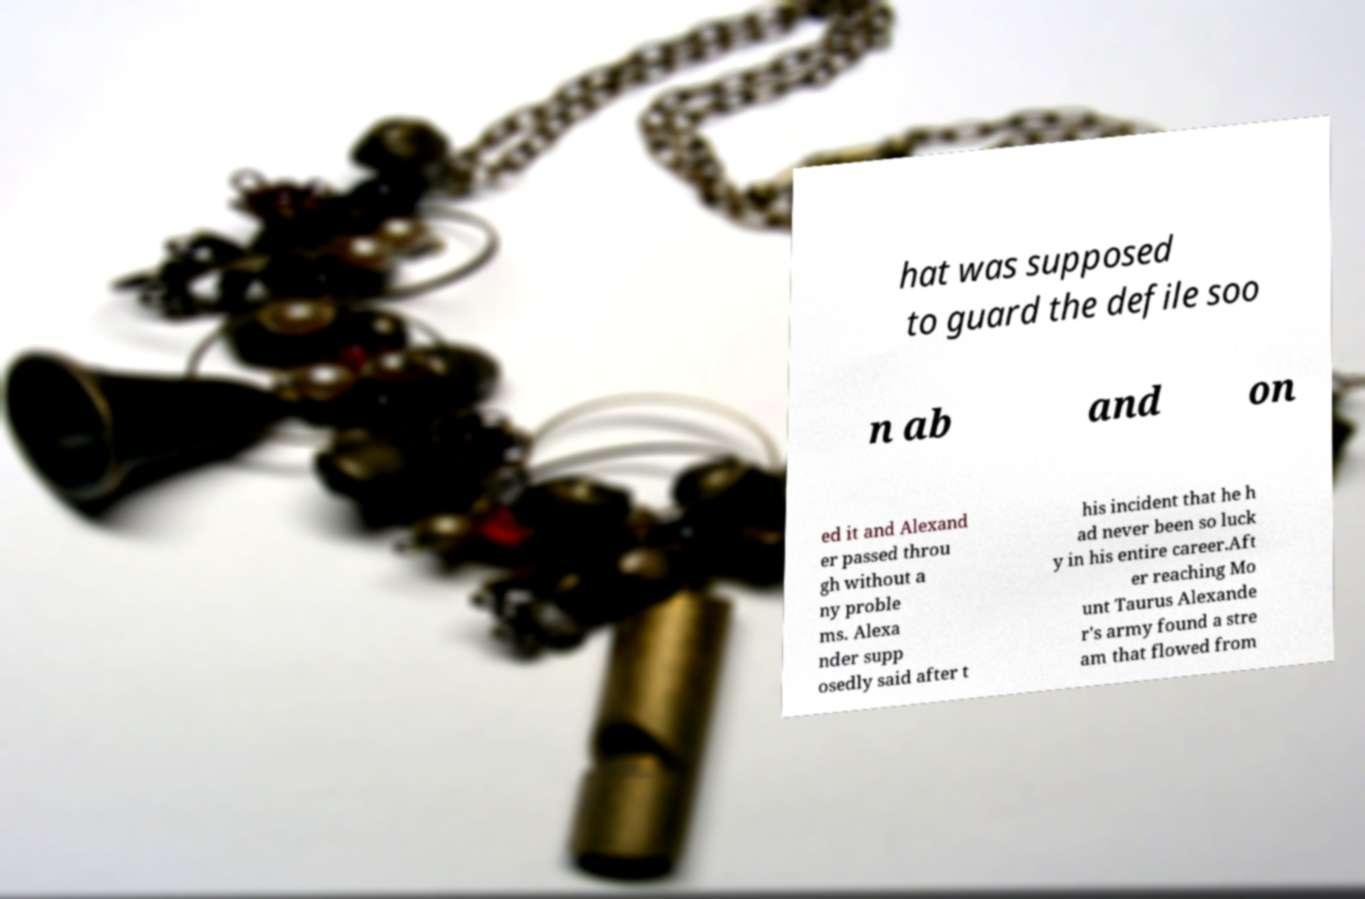Could you extract and type out the text from this image? hat was supposed to guard the defile soo n ab and on ed it and Alexand er passed throu gh without a ny proble ms. Alexa nder supp osedly said after t his incident that he h ad never been so luck y in his entire career.Aft er reaching Mo unt Taurus Alexande r's army found a stre am that flowed from 